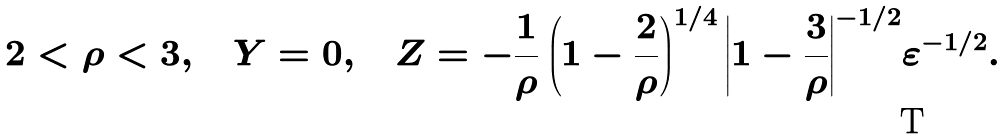<formula> <loc_0><loc_0><loc_500><loc_500>2 < \rho < 3 , \quad Y = 0 , \quad Z = - { \frac { 1 } { \rho } } \left ( { 1 - { \frac { 2 } { \rho } } } \right ) ^ { 1 / 4 } { \left | { 1 - { \frac { 3 } { \rho } } } \right | } ^ { - 1 / 2 } \varepsilon ^ { - 1 / 2 } .</formula> 